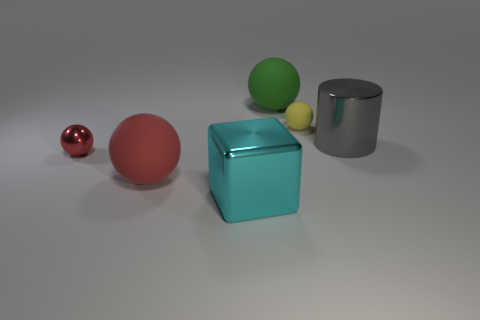Subtract all gray balls. Subtract all cyan cubes. How many balls are left? 4 Add 4 big yellow rubber things. How many objects exist? 10 Subtract all cubes. How many objects are left? 5 Subtract all big gray rubber objects. Subtract all cyan blocks. How many objects are left? 5 Add 3 big red spheres. How many big red spheres are left? 4 Add 4 tiny cyan blocks. How many tiny cyan blocks exist? 4 Subtract 0 blue cubes. How many objects are left? 6 